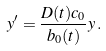<formula> <loc_0><loc_0><loc_500><loc_500>y ^ { \prime } = \frac { D ( t ) c _ { 0 } } { b _ { 0 } ( t ) } y \, .</formula> 